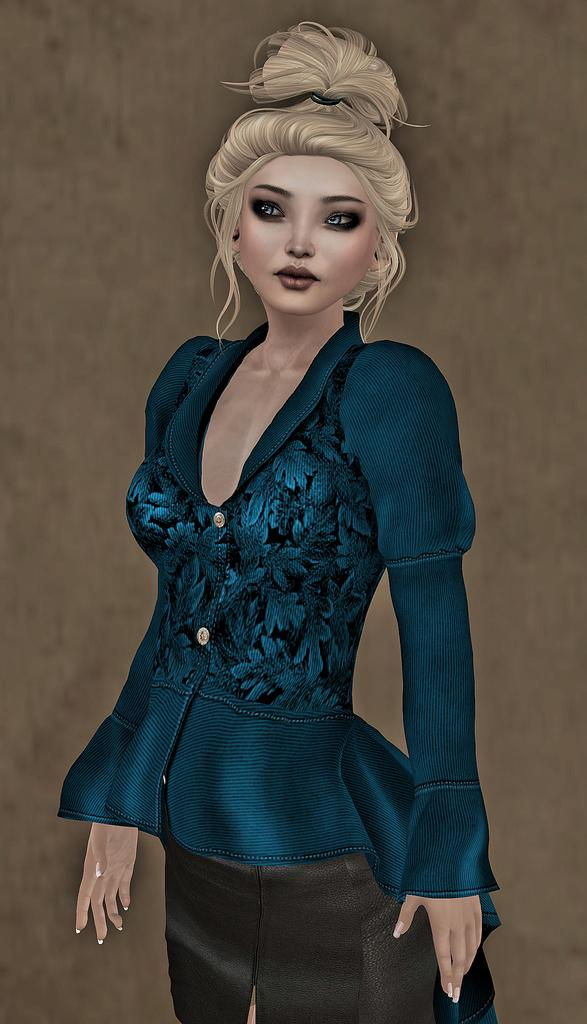What type of image is being described? The image is animated. Can you describe any characters or figures in the image? There is a lady in the image. What can be seen behind the lady in the image? There is a background in the image. What type of calculator is being used by the lady in the image? There is no calculator present in the image. What kind of motion is the lady performing in the image? The image is static, so the lady is not performing any motion. 